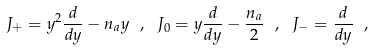<formula> <loc_0><loc_0><loc_500><loc_500>J _ { + } = y ^ { 2 } \frac { d } { d y } - n _ { a } y \ , \ J _ { 0 } = y \frac { d } { d y } - \frac { n _ { a } } { 2 } \ , \ J _ { - } = \frac { d } { d y } \ ,</formula> 